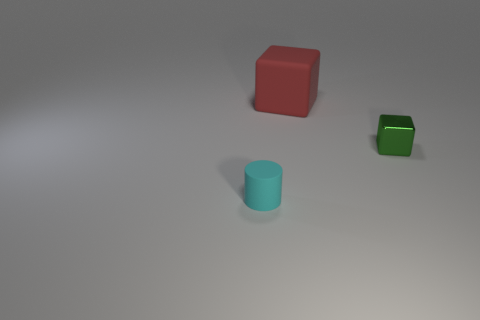There is a object that is behind the green shiny thing; are there any tiny cyan things behind it?
Offer a very short reply. No. There is a tiny cyan matte thing; does it have the same shape as the rubber thing behind the shiny cube?
Offer a very short reply. No. What color is the matte thing to the right of the tiny matte cylinder?
Make the answer very short. Red. There is a rubber thing in front of the rubber thing that is behind the cylinder; what size is it?
Offer a very short reply. Small. There is a object that is on the left side of the red block; does it have the same shape as the big red object?
Provide a short and direct response. No. There is another object that is the same shape as the red object; what is its material?
Keep it short and to the point. Metal. How many objects are matte objects that are behind the small green object or objects that are in front of the red cube?
Provide a succinct answer. 3. There is a matte cylinder; does it have the same color as the thing that is behind the tiny metal thing?
Ensure brevity in your answer.  No. There is another object that is the same material as the small cyan object; what shape is it?
Offer a terse response. Cube. How many tiny rubber objects are there?
Provide a succinct answer. 1. 